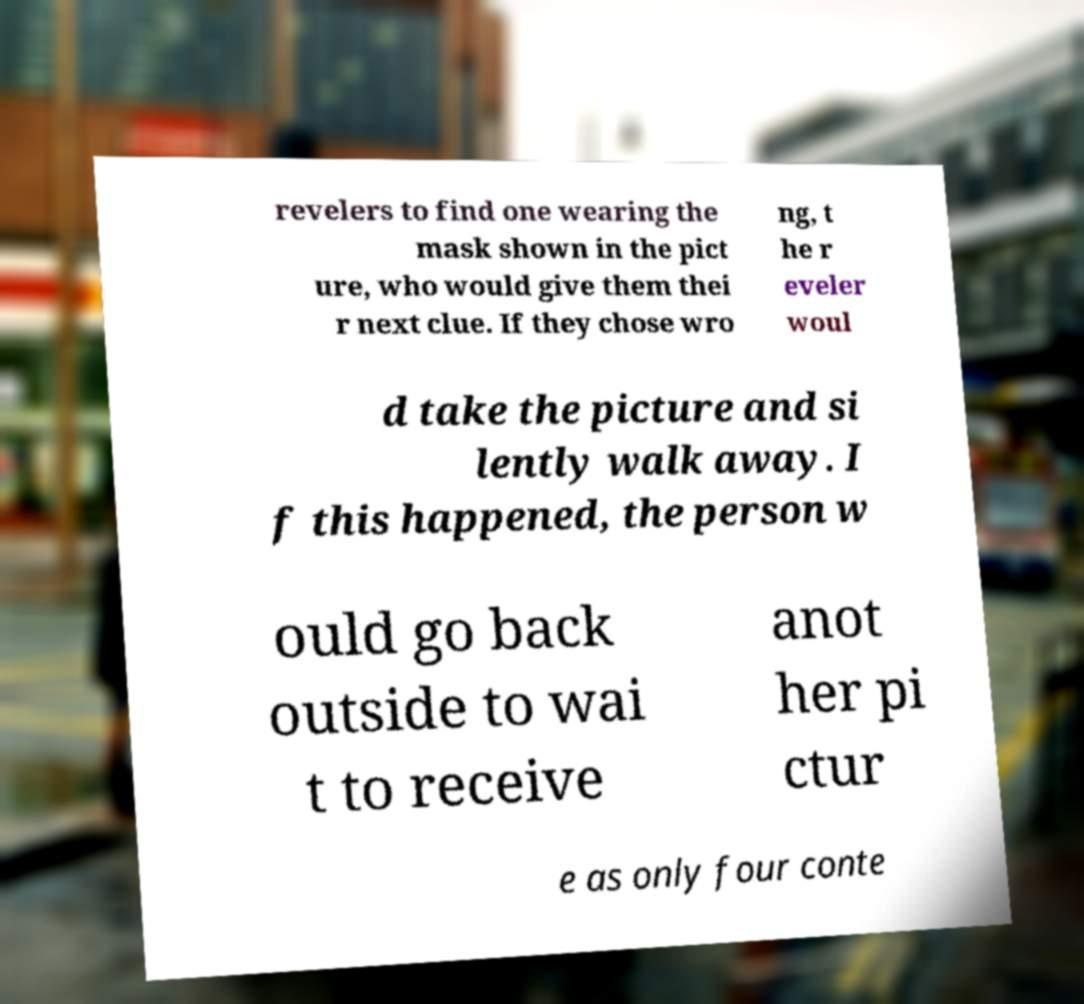Please identify and transcribe the text found in this image. revelers to find one wearing the mask shown in the pict ure, who would give them thei r next clue. If they chose wro ng, t he r eveler woul d take the picture and si lently walk away. I f this happened, the person w ould go back outside to wai t to receive anot her pi ctur e as only four conte 